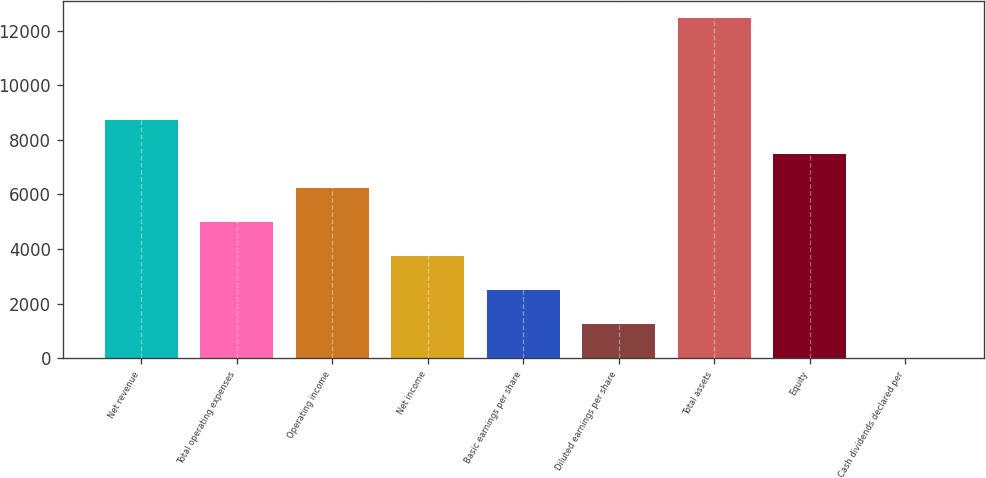Convert chart to OTSL. <chart><loc_0><loc_0><loc_500><loc_500><bar_chart><fcel>Net revenue<fcel>Total operating expenses<fcel>Operating income<fcel>Net income<fcel>Basic earnings per share<fcel>Diluted earnings per share<fcel>Total assets<fcel>Equity<fcel>Cash dividends declared per<nl><fcel>8723.45<fcel>4984.88<fcel>6231.07<fcel>3738.69<fcel>2492.5<fcel>1246.31<fcel>12462<fcel>7477.26<fcel>0.12<nl></chart> 